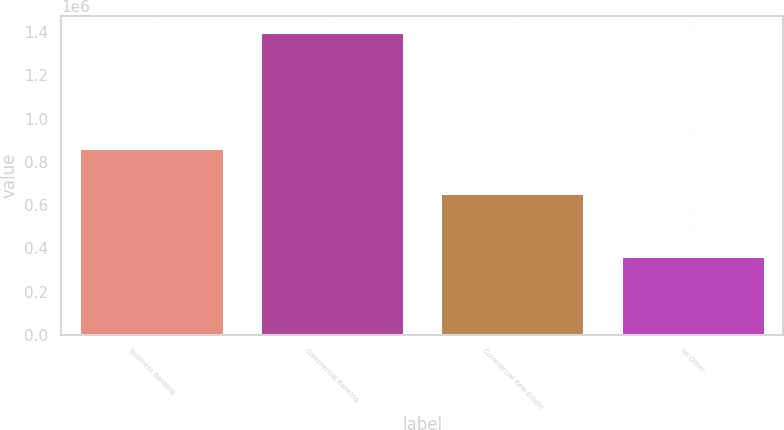<chart> <loc_0><loc_0><loc_500><loc_500><bar_chart><fcel>Business Banking<fcel>Commercial Banking<fcel>Commercial Real Estate<fcel>All Other<nl><fcel>864366<fcel>1.40187e+06<fcel>654389<fcel>363293<nl></chart> 